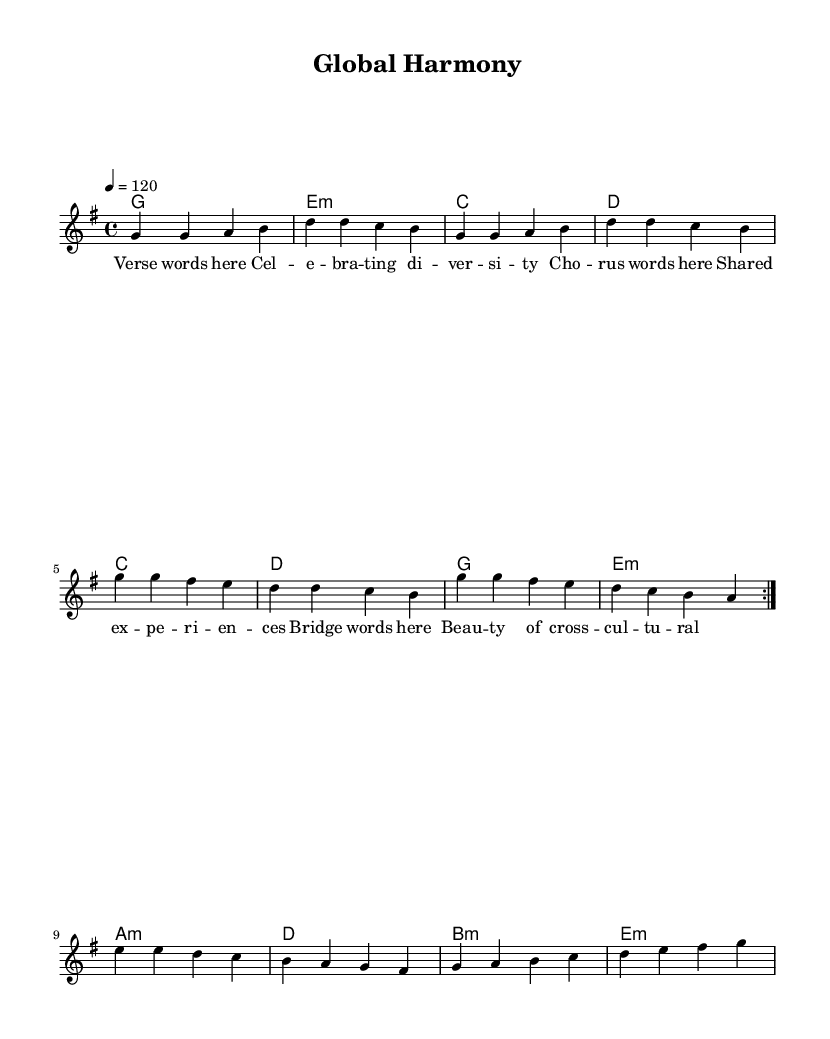what is the key signature of this music? The key signature is G major, which has one sharp (F#). This is determined from the initial setup in the global context of the music.
Answer: G major what is the time signature of this music? The time signature is 4/4, which indicates that there are four beats in a measure and the quarter note gets one beat. This is explicitly stated in the global context of the score.
Answer: 4/4 what is the tempo marking for this piece? The tempo marking is 120 beats per minute, indicating the speed of the piece. This is defined in the global section of the score where it states '4 = 120'.
Answer: 120 how many times is the melody repeated in this piece? The melody is repeated twice, as indicated by the 'repeat volta 2' command within the melody section. This specifies that the following segment will be played twice.
Answer: 2 which chord is played at the beginning of the fourth measure? The chord played at the beginning of the fourth measure is D major, as shown in the harmonies section where the chord sequence starts with G and progresses to E minor, C, and then D.
Answer: D what theme does the lyrics of the chorus represent? The theme of the chorus lyrics represents shared experiences, indicative of the piece’s focus on cultural diversity and community interaction. This interpretation is drawn from the specific lyrics provided in the chorus section.
Answer: Shared experiences what is significant about the bridge lyrics? The bridge lyrics emphasize the beauty of cross-cultural interactions, highlighting the essence of the song's celebration of diversity. This information emerges from analyzing the content of the bridge lyrics compared to the overall theme of the music.
Answer: Beauty of cross-cultural 